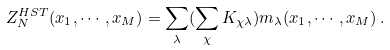Convert formula to latex. <formula><loc_0><loc_0><loc_500><loc_500>Z _ { N } ^ { H S T } ( x _ { 1 } , \cdots , x _ { M } ) = \sum _ { \lambda } ( \sum _ { \chi } K _ { \chi \lambda } ) m _ { \lambda } ( x _ { 1 } , \cdots , x _ { M } ) \, .</formula> 